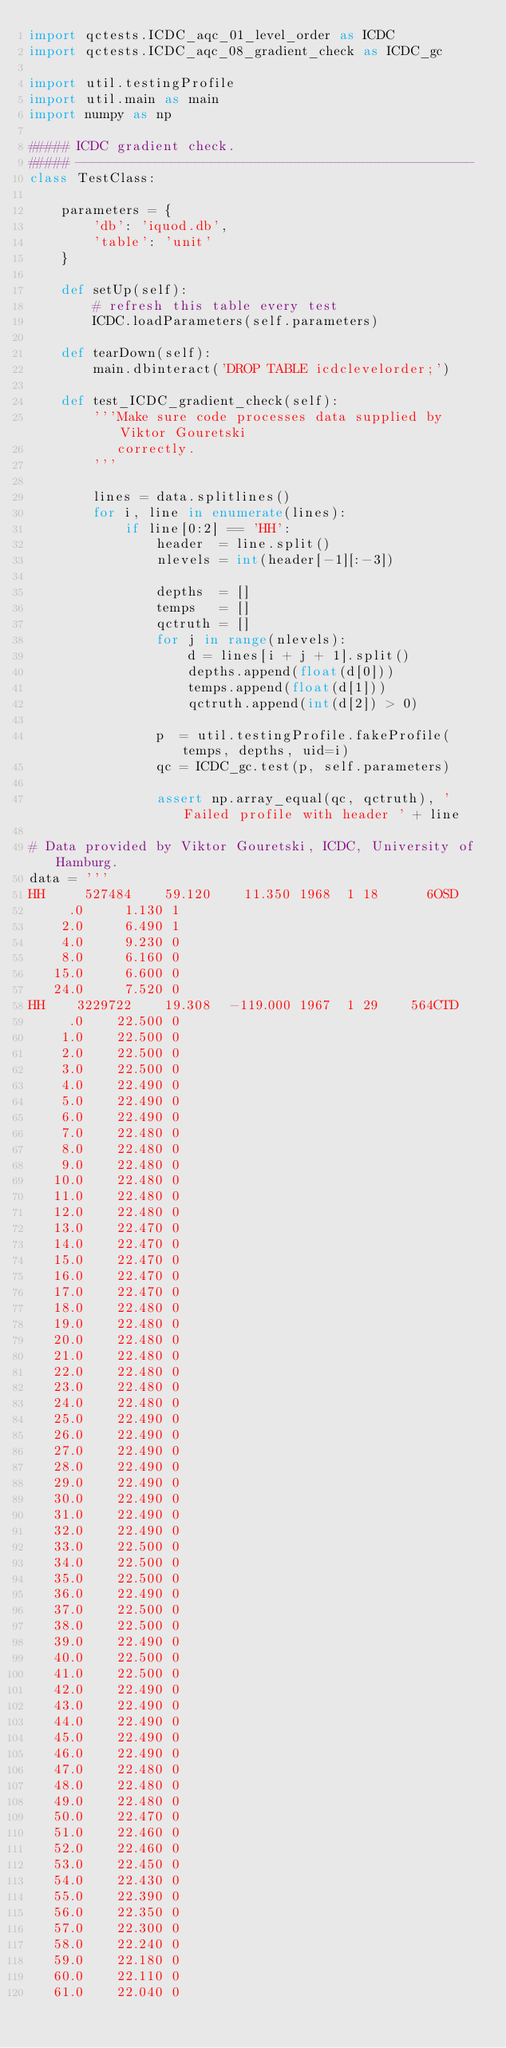Convert code to text. <code><loc_0><loc_0><loc_500><loc_500><_Python_>import qctests.ICDC_aqc_01_level_order as ICDC
import qctests.ICDC_aqc_08_gradient_check as ICDC_gc

import util.testingProfile
import util.main as main
import numpy as np

##### ICDC gradient check.
##### --------------------------------------------------
class TestClass:

    parameters = {
        'db': 'iquod.db',
        'table': 'unit'
    }

    def setUp(self):
        # refresh this table every test
        ICDC.loadParameters(self.parameters)

    def tearDown(self):
        main.dbinteract('DROP TABLE icdclevelorder;')

    def test_ICDC_gradient_check(self):
        '''Make sure code processes data supplied by Viktor Gouretski
           correctly.
        '''

        lines = data.splitlines()
        for i, line in enumerate(lines):
            if line[0:2] == 'HH':
                header  = line.split()
                nlevels = int(header[-1][:-3])
                
                depths  = []
                temps   = []
                qctruth = []
                for j in range(nlevels):
                    d = lines[i + j + 1].split()
                    depths.append(float(d[0]))
                    temps.append(float(d[1]))
                    qctruth.append(int(d[2]) > 0)
                
                p  = util.testingProfile.fakeProfile(temps, depths, uid=i)
                qc = ICDC_gc.test(p, self.parameters)

                assert np.array_equal(qc, qctruth), 'Failed profile with header ' + line

# Data provided by Viktor Gouretski, ICDC, University of Hamburg.
data = '''
HH     527484    59.120    11.350 1968  1 18      6OSD
     .0     1.130 1
    2.0     6.490 1
    4.0     9.230 0
    8.0     6.160 0
   15.0     6.600 0
   24.0     7.520 0
HH    3229722    19.308  -119.000 1967  1 29    564CTD
     .0    22.500 0
    1.0    22.500 0
    2.0    22.500 0
    3.0    22.500 0
    4.0    22.490 0
    5.0    22.490 0
    6.0    22.490 0
    7.0    22.480 0
    8.0    22.480 0
    9.0    22.480 0
   10.0    22.480 0
   11.0    22.480 0
   12.0    22.480 0
   13.0    22.470 0
   14.0    22.470 0
   15.0    22.470 0
   16.0    22.470 0
   17.0    22.470 0
   18.0    22.480 0
   19.0    22.480 0
   20.0    22.480 0
   21.0    22.480 0
   22.0    22.480 0
   23.0    22.480 0
   24.0    22.480 0
   25.0    22.490 0
   26.0    22.490 0
   27.0    22.490 0
   28.0    22.490 0
   29.0    22.490 0
   30.0    22.490 0
   31.0    22.490 0
   32.0    22.490 0
   33.0    22.500 0
   34.0    22.500 0
   35.0    22.500 0
   36.0    22.490 0
   37.0    22.500 0
   38.0    22.500 0
   39.0    22.490 0
   40.0    22.500 0
   41.0    22.500 0
   42.0    22.490 0
   43.0    22.490 0
   44.0    22.490 0
   45.0    22.490 0
   46.0    22.490 0
   47.0    22.480 0
   48.0    22.480 0
   49.0    22.480 0
   50.0    22.470 0
   51.0    22.460 0
   52.0    22.460 0
   53.0    22.450 0
   54.0    22.430 0
   55.0    22.390 0
   56.0    22.350 0
   57.0    22.300 0
   58.0    22.240 0
   59.0    22.180 0
   60.0    22.110 0
   61.0    22.040 0</code> 